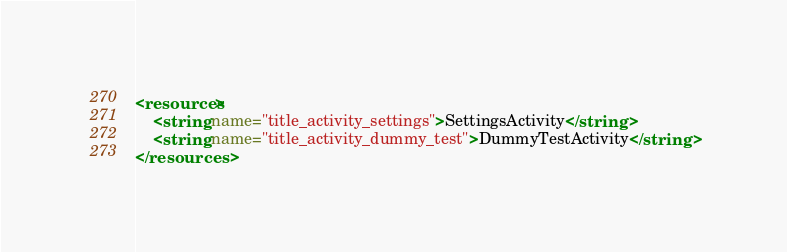Convert code to text. <code><loc_0><loc_0><loc_500><loc_500><_XML_><resources>
    <string name="title_activity_settings">SettingsActivity</string>
    <string name="title_activity_dummy_test">DummyTestActivity</string>
</resources>
</code> 